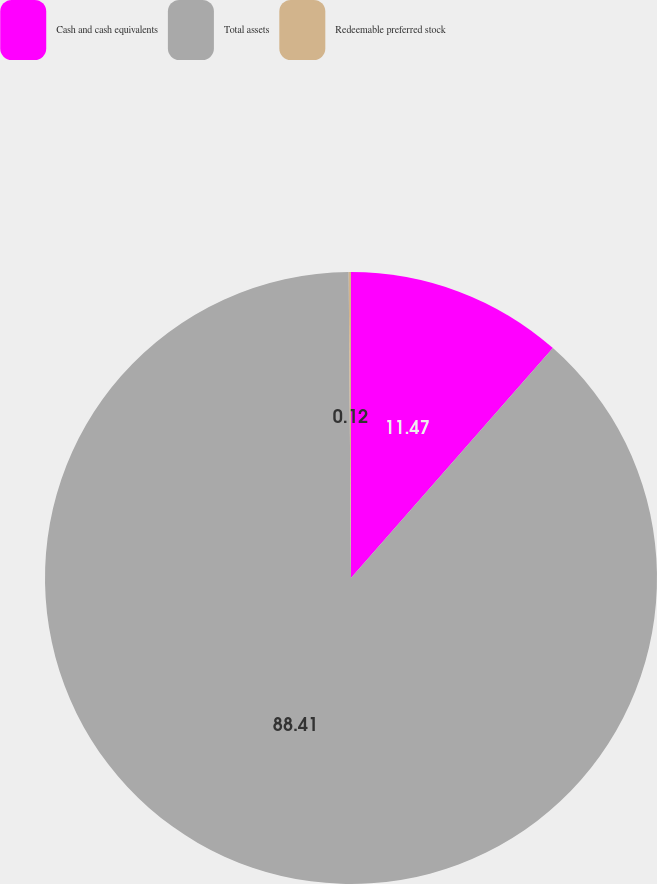<chart> <loc_0><loc_0><loc_500><loc_500><pie_chart><fcel>Cash and cash equivalents<fcel>Total assets<fcel>Redeemable preferred stock<nl><fcel>11.47%<fcel>88.41%<fcel>0.12%<nl></chart> 